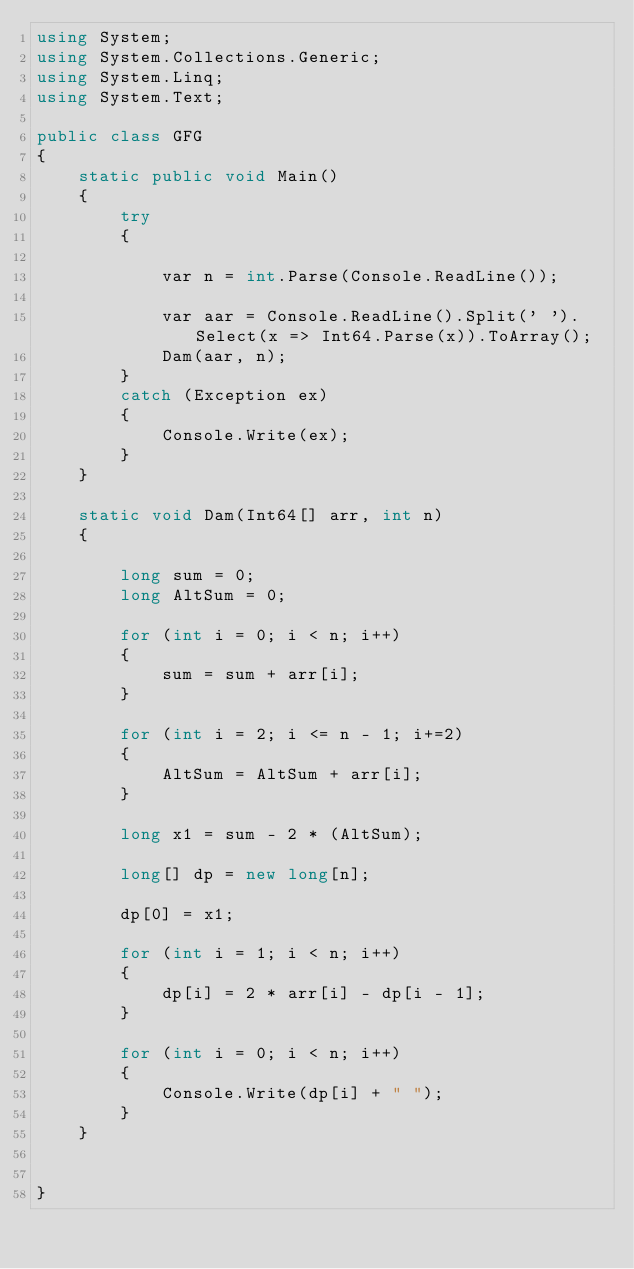Convert code to text. <code><loc_0><loc_0><loc_500><loc_500><_C#_>using System;
using System.Collections.Generic;
using System.Linq;
using System.Text;

public class GFG
{
    static public void Main()
    {
        try
        {

            var n = int.Parse(Console.ReadLine());

            var aar = Console.ReadLine().Split(' ').Select(x => Int64.Parse(x)).ToArray();
            Dam(aar, n);
        }
        catch (Exception ex)
        {
            Console.Write(ex);
        }
    }

    static void Dam(Int64[] arr, int n)
    {

        long sum = 0;
        long AltSum = 0;

        for (int i = 0; i < n; i++)
        {
            sum = sum + arr[i];
        }

        for (int i = 2; i <= n - 1; i+=2)
        {
            AltSum = AltSum + arr[i];
        }

        long x1 = sum - 2 * (AltSum);

        long[] dp = new long[n];

        dp[0] = x1;

        for (int i = 1; i < n; i++)
        {
            dp[i] = 2 * arr[i] - dp[i - 1];
        }

        for (int i = 0; i < n; i++)
        {
            Console.Write(dp[i] + " ");
        }
    }


}</code> 